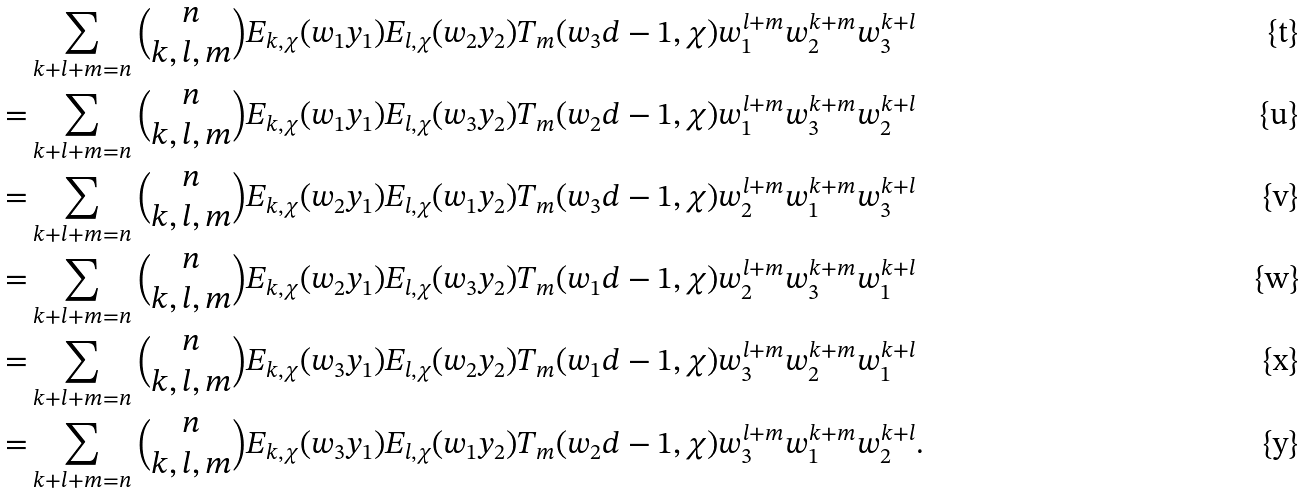<formula> <loc_0><loc_0><loc_500><loc_500>& \sum _ { k + l + m = n } { \binom { n } { k , l , m } } E _ { k , \chi } ( w _ { 1 } y _ { 1 } ) E _ { l , \chi } ( w _ { 2 } y _ { 2 } ) T _ { m } ( w _ { 3 } d - 1 , \chi ) w _ { 1 } ^ { l + m } w _ { 2 } ^ { k + m } w _ { 3 } ^ { k + l } \\ = & \sum _ { k + l + m = n } { \binom { n } { k , l , m } } E _ { k , \chi } ( w _ { 1 } y _ { 1 } ) E _ { l , \chi } ( w _ { 3 } y _ { 2 } ) T _ { m } ( w _ { 2 } d - 1 , \chi ) w _ { 1 } ^ { l + m } w _ { 3 } ^ { k + m } w _ { 2 } ^ { k + l } \\ = & \sum _ { k + l + m = n } { \binom { n } { k , l , m } } E _ { k , \chi } ( w _ { 2 } y _ { 1 } ) E _ { l , \chi } ( w _ { 1 } y _ { 2 } ) T _ { m } ( w _ { 3 } d - 1 , \chi ) w _ { 2 } ^ { l + m } w _ { 1 } ^ { k + m } w _ { 3 } ^ { k + l } \\ = & \sum _ { k + l + m = n } { \binom { n } { k , l , m } } E _ { k , \chi } ( w _ { 2 } y _ { 1 } ) E _ { l , \chi } ( w _ { 3 } y _ { 2 } ) T _ { m } ( w _ { 1 } d - 1 , \chi ) w _ { 2 } ^ { l + m } w _ { 3 } ^ { k + m } w _ { 1 } ^ { k + l } \\ = & \sum _ { k + l + m = n } { \binom { n } { k , l , m } } E _ { k , \chi } ( w _ { 3 } y _ { 1 } ) E _ { l , \chi } ( w _ { 2 } y _ { 2 } ) T _ { m } ( w _ { 1 } d - 1 , \chi ) w _ { 3 } ^ { l + m } w _ { 2 } ^ { k + m } w _ { 1 } ^ { k + l } \\ = & \sum _ { k + l + m = n } { \binom { n } { k , l , m } } E _ { k , \chi } ( w _ { 3 } y _ { 1 } ) E _ { l , \chi } ( w _ { 1 } y _ { 2 } ) T _ { m } ( w _ { 2 } d - 1 , \chi ) w _ { 3 } ^ { l + m } w _ { 1 } ^ { k + m } w _ { 2 } ^ { k + l } .</formula> 